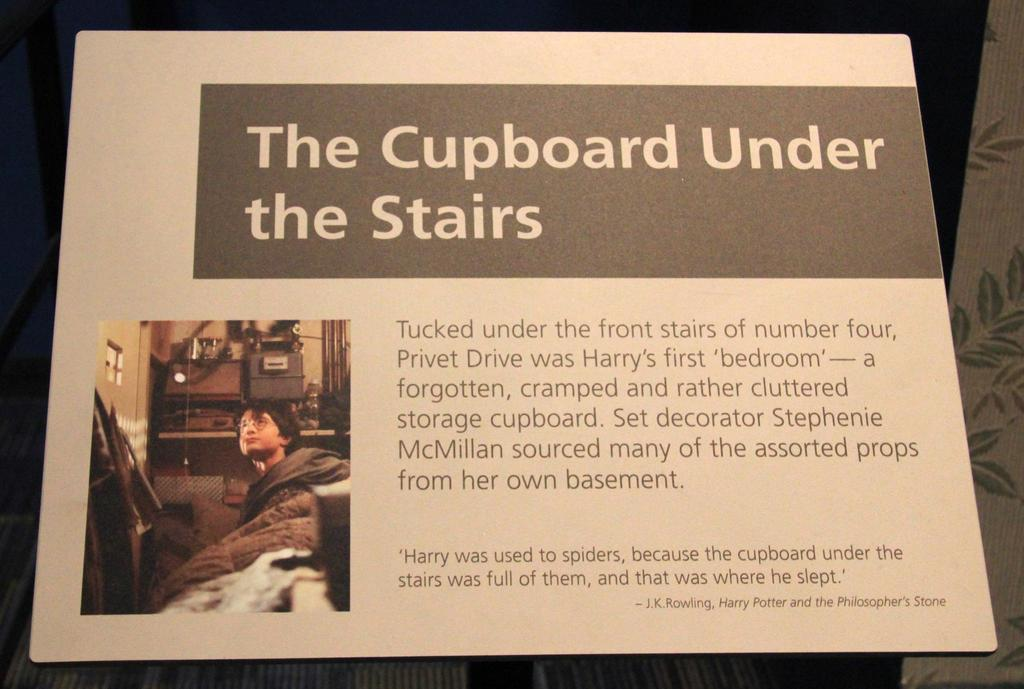<image>
Relay a brief, clear account of the picture shown. Sign which says "The Cupboard Under the Stairs" on it. 